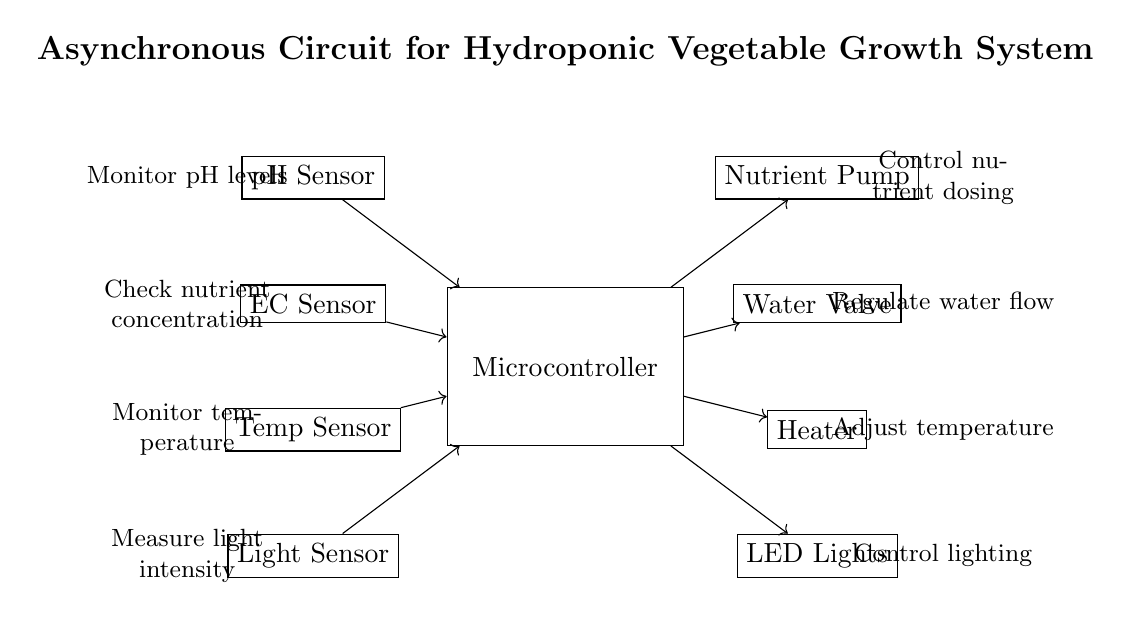What is the main control unit in the circuit? The main control unit is represented by the rectangular block labeled "Microcontroller." It processes data from the sensors and controls the actuators based on that information.
Answer: Microcontroller How many sensors are used in the circuit? There are four sensors connected to the microcontroller: pH Sensor, EC Sensor, Temperature Sensor, and Light Sensor. Each sensor provides specific data for monitoring.
Answer: Four What is the purpose of the LED lights in the circuit? The LED lights are used to control lighting, which is essential for plant growth in a hydroponic system. They are connected to the microcontroller, allowing for automated lighting control based on conditions.
Answer: Control lighting Which sensor measures nutrient concentration? The EC Sensor measures the nutrient concentration in the hydroponic system. It provides critical information to the microcontroller to ensure the correct nutrient levels are maintained for optimal plant growth.
Answer: EC Sensor Which actuator regulates water flow? The Water Valve acts as the actuator that regulates water flow in the hydroponic system. It is controlled by the microcontroller based on inputs from the various sensors.
Answer: Water Valve What type of circuit is this? This is an asynchronous circuit. Asynchronous circuits operate without a global clock, relying on the immediate responses and interactions between components, such as sensors and actuators in this system.
Answer: Asynchronous How does the system monitor temperature? The system uses the Temperature Sensor, which sends temperature readings to the microcontroller. Based on this data, the microcontroller can adjust the Heater to maintain the desired temperature for optimal plant growth.
Answer: Temperature Sensor 